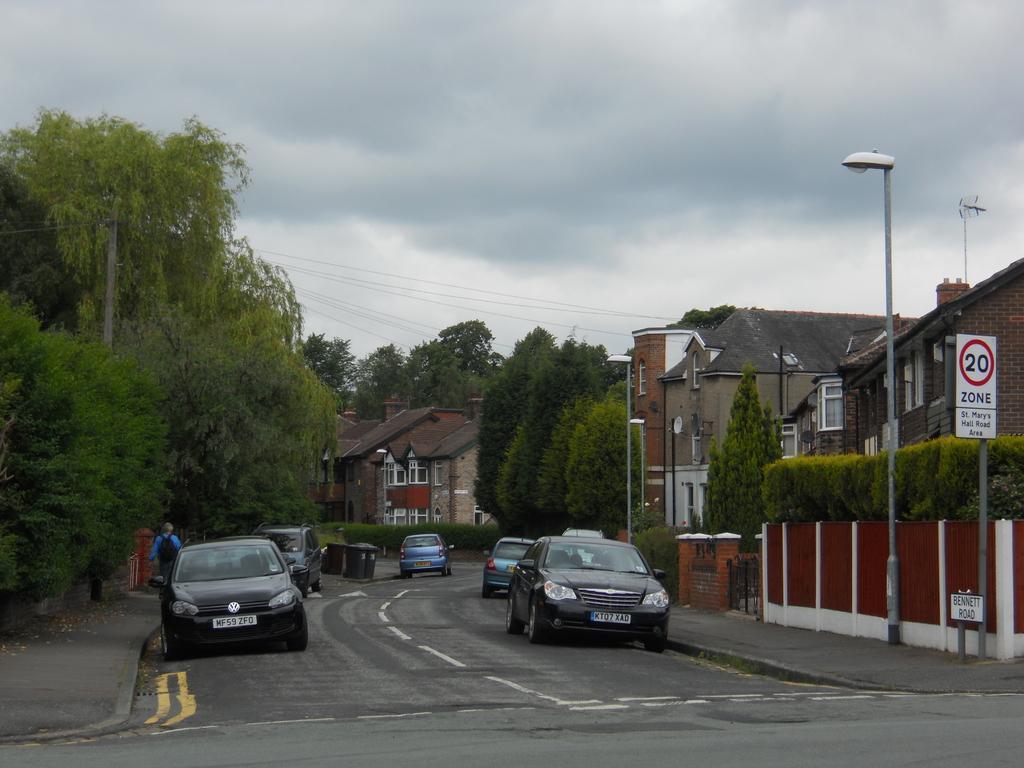Could you give a brief overview of what you see in this image? In this picture we can see few cars, trees, poles and buildings, on the left side of the image we can see a person, the person walking on the pathway, on the right side of the image we can see few sign boards, in the background we can see clouds. 